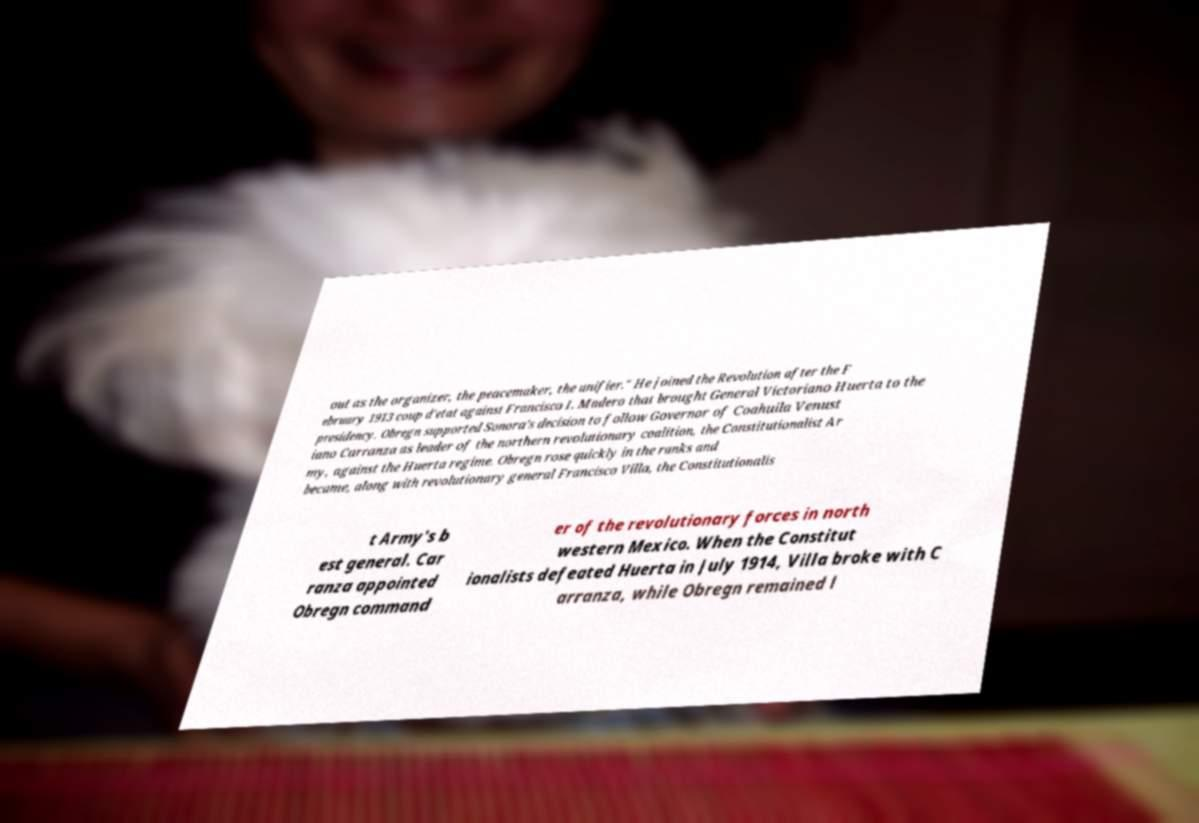There's text embedded in this image that I need extracted. Can you transcribe it verbatim? out as the organizer, the peacemaker, the unifier." He joined the Revolution after the F ebruary 1913 coup d'etat against Francisco I. Madero that brought General Victoriano Huerta to the presidency. Obregn supported Sonora's decision to follow Governor of Coahuila Venust iano Carranza as leader of the northern revolutionary coalition, the Constitutionalist Ar my, against the Huerta regime. Obregn rose quickly in the ranks and became, along with revolutionary general Francisco Villa, the Constitutionalis t Army's b est general. Car ranza appointed Obregn command er of the revolutionary forces in north western Mexico. When the Constitut ionalists defeated Huerta in July 1914, Villa broke with C arranza, while Obregn remained l 